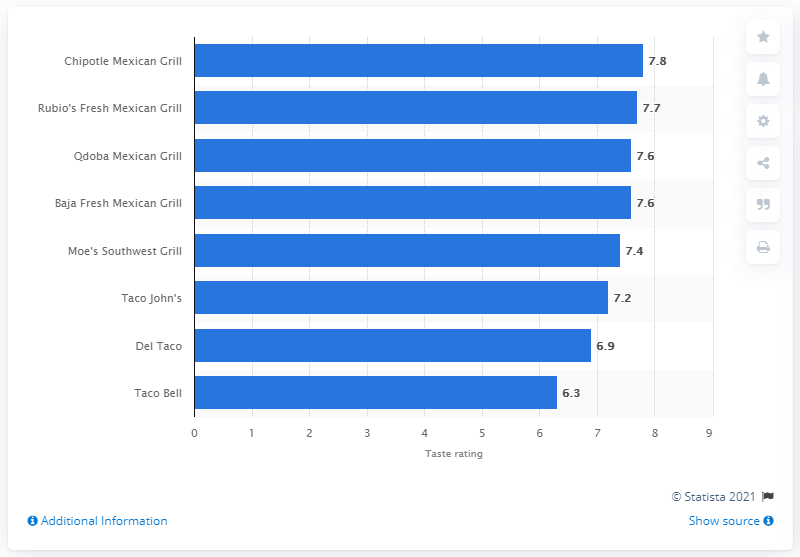Give some essential details in this illustration. Qdoba Mexican Eats received a taste rating of 7.6. 